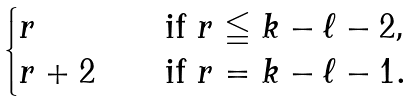Convert formula to latex. <formula><loc_0><loc_0><loc_500><loc_500>\begin{cases} r \quad & \text {if $r\leqq k-\ell-2$,} \\ r + 2 \quad & \text {if $r=k-\ell-1$} . \end{cases}</formula> 